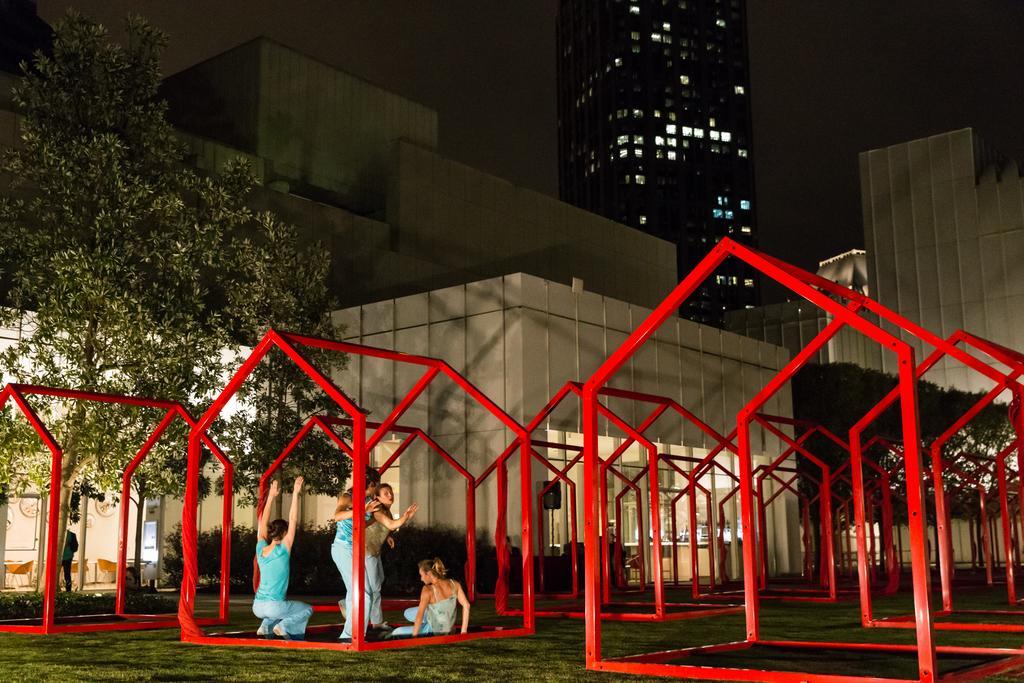Could you give a brief overview of what you see in this image? Bottom of the image there is grass and few people are standing and sitting and there are some poles. Behind the poles there are some plants and trees. Top right side of the image there are some buildings and trees. 